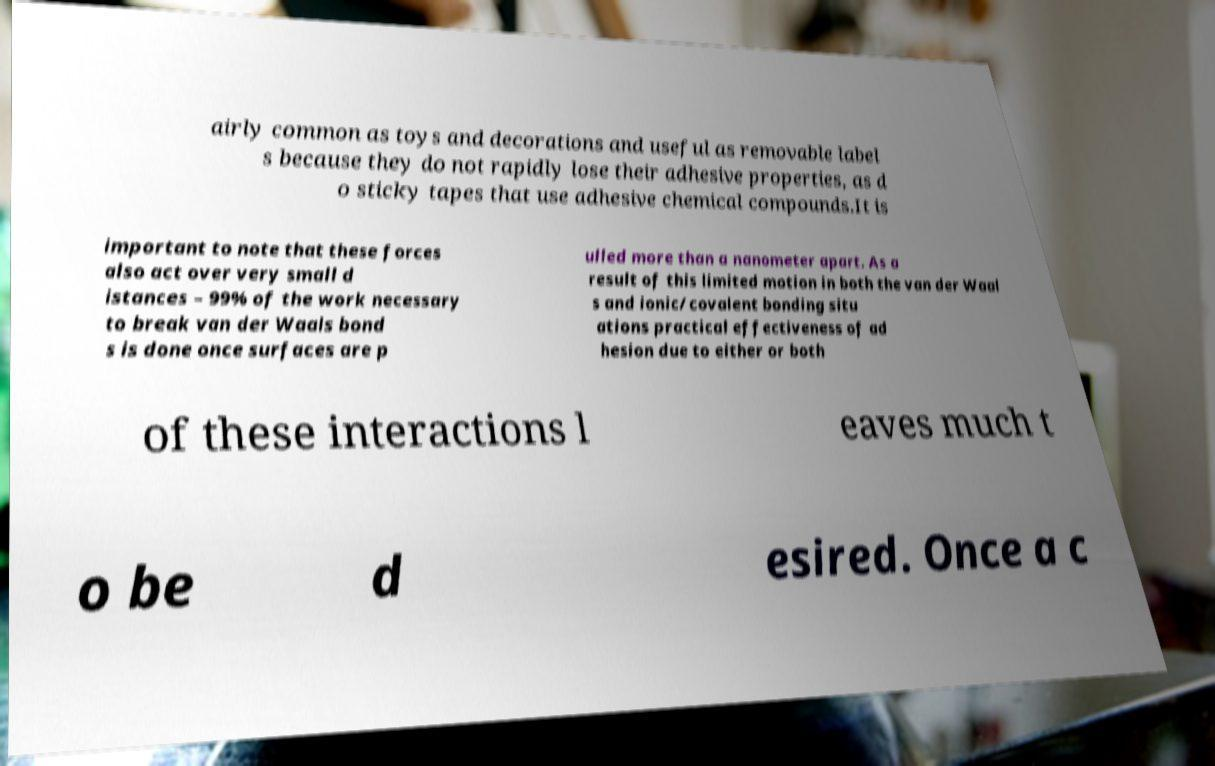For documentation purposes, I need the text within this image transcribed. Could you provide that? airly common as toys and decorations and useful as removable label s because they do not rapidly lose their adhesive properties, as d o sticky tapes that use adhesive chemical compounds.It is important to note that these forces also act over very small d istances – 99% of the work necessary to break van der Waals bond s is done once surfaces are p ulled more than a nanometer apart. As a result of this limited motion in both the van der Waal s and ionic/covalent bonding situ ations practical effectiveness of ad hesion due to either or both of these interactions l eaves much t o be d esired. Once a c 